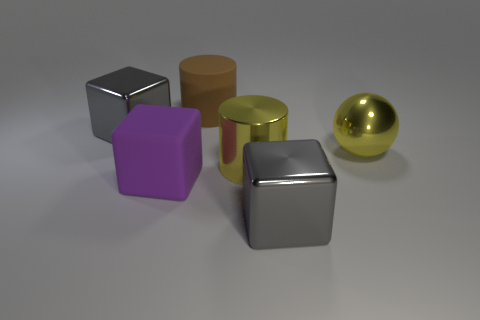What number of other objects are there of the same size as the brown cylinder?
Ensure brevity in your answer.  5. What is the size of the object that is the same color as the big ball?
Give a very brief answer. Large. Are there more big purple matte objects on the right side of the yellow metal ball than big yellow things?
Your answer should be very brief. No. Are there any other matte balls that have the same color as the big ball?
Ensure brevity in your answer.  No. What is the color of the rubber cylinder that is the same size as the purple rubber object?
Your answer should be compact. Brown. What number of gray shiny blocks are left of the big shiny block that is behind the large yellow ball?
Offer a very short reply. 0. What number of objects are either large gray metal blocks that are left of the purple rubber block or shiny spheres?
Offer a very short reply. 2. What number of large blocks are the same material as the large purple thing?
Give a very brief answer. 0. What shape is the big metal thing that is the same color as the sphere?
Give a very brief answer. Cylinder. Are there the same number of shiny things in front of the sphere and large brown matte blocks?
Your answer should be very brief. No. 